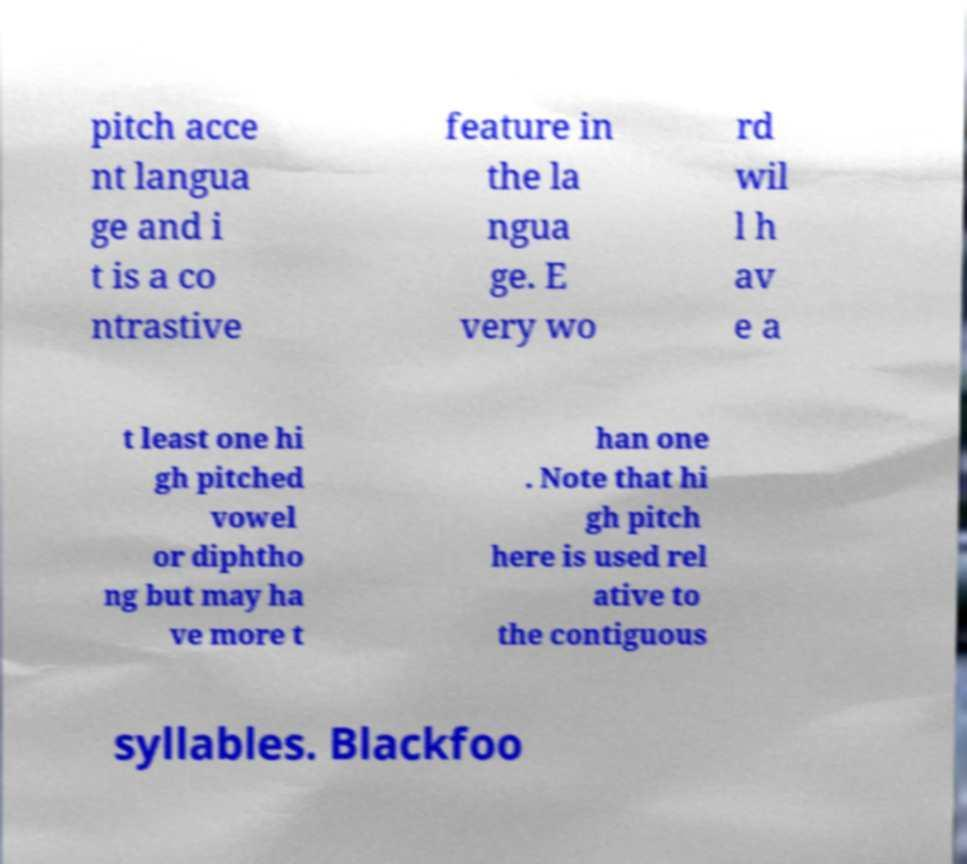What messages or text are displayed in this image? I need them in a readable, typed format. pitch acce nt langua ge and i t is a co ntrastive feature in the la ngua ge. E very wo rd wil l h av e a t least one hi gh pitched vowel or diphtho ng but may ha ve more t han one . Note that hi gh pitch here is used rel ative to the contiguous syllables. Blackfoo 